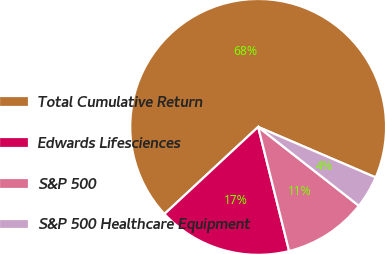Convert chart to OTSL. <chart><loc_0><loc_0><loc_500><loc_500><pie_chart><fcel>Total Cumulative Return<fcel>Edwards Lifesciences<fcel>S&P 500<fcel>S&P 500 Healthcare Equipment<nl><fcel>68.38%<fcel>16.97%<fcel>10.54%<fcel>4.11%<nl></chart> 